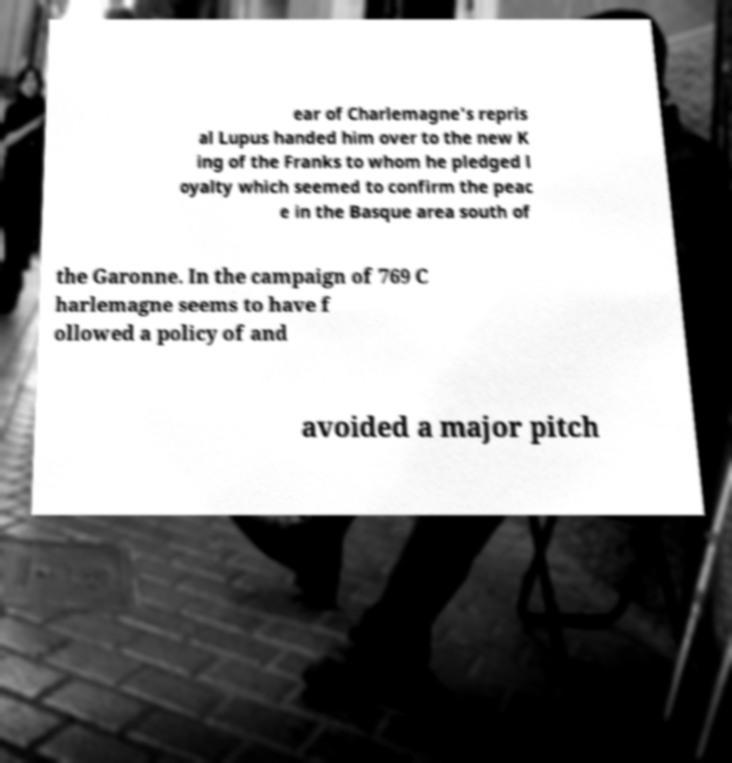Could you assist in decoding the text presented in this image and type it out clearly? ear of Charlemagne's repris al Lupus handed him over to the new K ing of the Franks to whom he pledged l oyalty which seemed to confirm the peac e in the Basque area south of the Garonne. In the campaign of 769 C harlemagne seems to have f ollowed a policy of and avoided a major pitch 